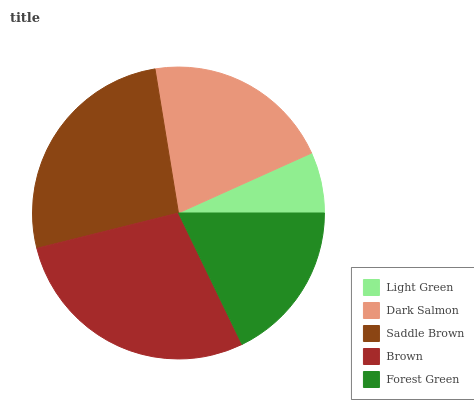Is Light Green the minimum?
Answer yes or no. Yes. Is Brown the maximum?
Answer yes or no. Yes. Is Dark Salmon the minimum?
Answer yes or no. No. Is Dark Salmon the maximum?
Answer yes or no. No. Is Dark Salmon greater than Light Green?
Answer yes or no. Yes. Is Light Green less than Dark Salmon?
Answer yes or no. Yes. Is Light Green greater than Dark Salmon?
Answer yes or no. No. Is Dark Salmon less than Light Green?
Answer yes or no. No. Is Dark Salmon the high median?
Answer yes or no. Yes. Is Dark Salmon the low median?
Answer yes or no. Yes. Is Saddle Brown the high median?
Answer yes or no. No. Is Light Green the low median?
Answer yes or no. No. 